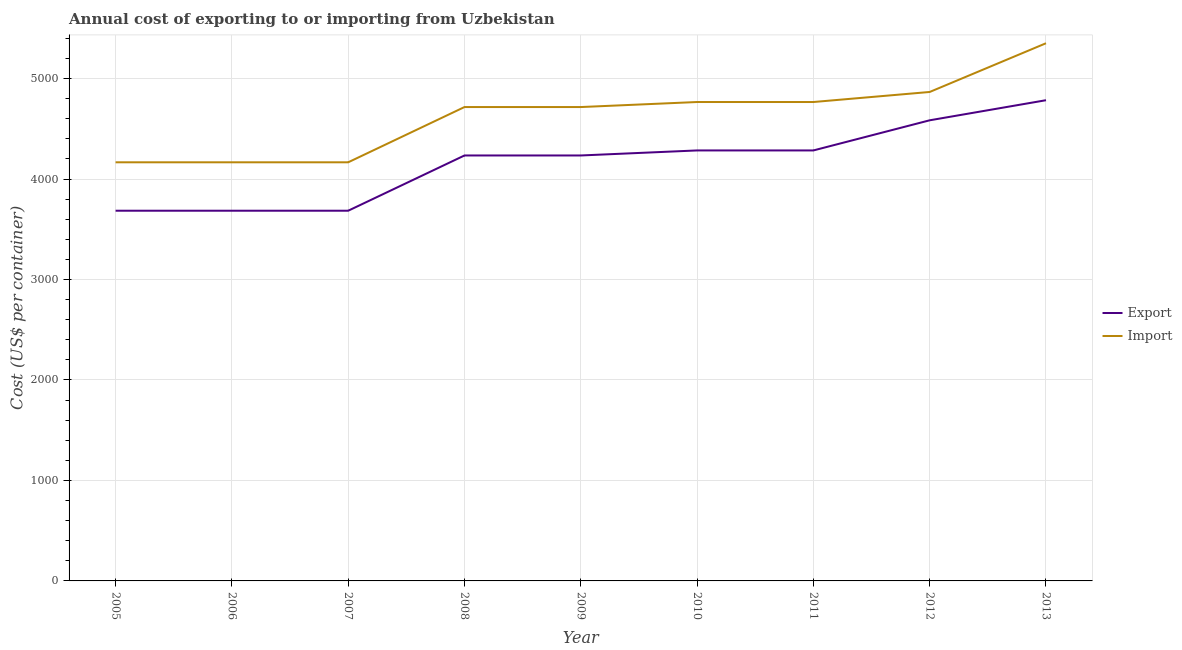Is the number of lines equal to the number of legend labels?
Your response must be concise. Yes. What is the import cost in 2012?
Your answer should be very brief. 4867. Across all years, what is the maximum import cost?
Provide a short and direct response. 5352. Across all years, what is the minimum import cost?
Offer a very short reply. 4167. In which year was the export cost maximum?
Give a very brief answer. 2013. What is the total export cost in the graph?
Offer a terse response. 3.75e+04. What is the difference between the export cost in 2008 and that in 2011?
Your answer should be very brief. -50. What is the difference between the import cost in 2007 and the export cost in 2011?
Provide a short and direct response. -118. What is the average import cost per year?
Provide a short and direct response. 4632. In the year 2006, what is the difference between the export cost and import cost?
Your answer should be very brief. -482. In how many years, is the export cost greater than 3800 US$?
Ensure brevity in your answer.  6. What is the ratio of the export cost in 2010 to that in 2012?
Offer a terse response. 0.93. Is the difference between the export cost in 2008 and 2013 greater than the difference between the import cost in 2008 and 2013?
Offer a very short reply. Yes. What is the difference between the highest and the second highest import cost?
Offer a very short reply. 485. What is the difference between the highest and the lowest import cost?
Give a very brief answer. 1185. Is the sum of the export cost in 2005 and 2011 greater than the maximum import cost across all years?
Offer a very short reply. Yes. Is the export cost strictly less than the import cost over the years?
Ensure brevity in your answer.  Yes. What is the difference between two consecutive major ticks on the Y-axis?
Your answer should be very brief. 1000. What is the title of the graph?
Keep it short and to the point. Annual cost of exporting to or importing from Uzbekistan. Does "Primary income" appear as one of the legend labels in the graph?
Provide a succinct answer. No. What is the label or title of the X-axis?
Provide a short and direct response. Year. What is the label or title of the Y-axis?
Keep it short and to the point. Cost (US$ per container). What is the Cost (US$ per container) in Export in 2005?
Offer a terse response. 3685. What is the Cost (US$ per container) of Import in 2005?
Provide a succinct answer. 4167. What is the Cost (US$ per container) in Export in 2006?
Provide a short and direct response. 3685. What is the Cost (US$ per container) in Import in 2006?
Make the answer very short. 4167. What is the Cost (US$ per container) in Export in 2007?
Provide a succinct answer. 3685. What is the Cost (US$ per container) of Import in 2007?
Make the answer very short. 4167. What is the Cost (US$ per container) of Export in 2008?
Offer a terse response. 4235. What is the Cost (US$ per container) of Import in 2008?
Offer a terse response. 4717. What is the Cost (US$ per container) of Export in 2009?
Provide a succinct answer. 4235. What is the Cost (US$ per container) of Import in 2009?
Your answer should be compact. 4717. What is the Cost (US$ per container) of Export in 2010?
Your response must be concise. 4285. What is the Cost (US$ per container) of Import in 2010?
Your answer should be compact. 4767. What is the Cost (US$ per container) of Export in 2011?
Keep it short and to the point. 4285. What is the Cost (US$ per container) of Import in 2011?
Provide a short and direct response. 4767. What is the Cost (US$ per container) in Export in 2012?
Provide a succinct answer. 4585. What is the Cost (US$ per container) in Import in 2012?
Ensure brevity in your answer.  4867. What is the Cost (US$ per container) of Export in 2013?
Your answer should be very brief. 4785. What is the Cost (US$ per container) of Import in 2013?
Ensure brevity in your answer.  5352. Across all years, what is the maximum Cost (US$ per container) of Export?
Provide a short and direct response. 4785. Across all years, what is the maximum Cost (US$ per container) of Import?
Provide a succinct answer. 5352. Across all years, what is the minimum Cost (US$ per container) in Export?
Make the answer very short. 3685. Across all years, what is the minimum Cost (US$ per container) in Import?
Ensure brevity in your answer.  4167. What is the total Cost (US$ per container) of Export in the graph?
Ensure brevity in your answer.  3.75e+04. What is the total Cost (US$ per container) of Import in the graph?
Offer a very short reply. 4.17e+04. What is the difference between the Cost (US$ per container) of Export in 2005 and that in 2006?
Your response must be concise. 0. What is the difference between the Cost (US$ per container) in Import in 2005 and that in 2006?
Your answer should be very brief. 0. What is the difference between the Cost (US$ per container) of Export in 2005 and that in 2008?
Offer a terse response. -550. What is the difference between the Cost (US$ per container) of Import in 2005 and that in 2008?
Your answer should be very brief. -550. What is the difference between the Cost (US$ per container) in Export in 2005 and that in 2009?
Ensure brevity in your answer.  -550. What is the difference between the Cost (US$ per container) of Import in 2005 and that in 2009?
Your response must be concise. -550. What is the difference between the Cost (US$ per container) of Export in 2005 and that in 2010?
Offer a very short reply. -600. What is the difference between the Cost (US$ per container) of Import in 2005 and that in 2010?
Your response must be concise. -600. What is the difference between the Cost (US$ per container) in Export in 2005 and that in 2011?
Make the answer very short. -600. What is the difference between the Cost (US$ per container) of Import in 2005 and that in 2011?
Offer a very short reply. -600. What is the difference between the Cost (US$ per container) in Export in 2005 and that in 2012?
Provide a succinct answer. -900. What is the difference between the Cost (US$ per container) of Import in 2005 and that in 2012?
Keep it short and to the point. -700. What is the difference between the Cost (US$ per container) of Export in 2005 and that in 2013?
Give a very brief answer. -1100. What is the difference between the Cost (US$ per container) in Import in 2005 and that in 2013?
Offer a terse response. -1185. What is the difference between the Cost (US$ per container) of Export in 2006 and that in 2007?
Make the answer very short. 0. What is the difference between the Cost (US$ per container) in Import in 2006 and that in 2007?
Give a very brief answer. 0. What is the difference between the Cost (US$ per container) in Export in 2006 and that in 2008?
Make the answer very short. -550. What is the difference between the Cost (US$ per container) in Import in 2006 and that in 2008?
Make the answer very short. -550. What is the difference between the Cost (US$ per container) of Export in 2006 and that in 2009?
Ensure brevity in your answer.  -550. What is the difference between the Cost (US$ per container) in Import in 2006 and that in 2009?
Give a very brief answer. -550. What is the difference between the Cost (US$ per container) in Export in 2006 and that in 2010?
Provide a short and direct response. -600. What is the difference between the Cost (US$ per container) in Import in 2006 and that in 2010?
Make the answer very short. -600. What is the difference between the Cost (US$ per container) of Export in 2006 and that in 2011?
Your answer should be very brief. -600. What is the difference between the Cost (US$ per container) in Import in 2006 and that in 2011?
Give a very brief answer. -600. What is the difference between the Cost (US$ per container) of Export in 2006 and that in 2012?
Provide a short and direct response. -900. What is the difference between the Cost (US$ per container) in Import in 2006 and that in 2012?
Your response must be concise. -700. What is the difference between the Cost (US$ per container) of Export in 2006 and that in 2013?
Ensure brevity in your answer.  -1100. What is the difference between the Cost (US$ per container) of Import in 2006 and that in 2013?
Provide a short and direct response. -1185. What is the difference between the Cost (US$ per container) of Export in 2007 and that in 2008?
Provide a succinct answer. -550. What is the difference between the Cost (US$ per container) of Import in 2007 and that in 2008?
Provide a succinct answer. -550. What is the difference between the Cost (US$ per container) in Export in 2007 and that in 2009?
Offer a terse response. -550. What is the difference between the Cost (US$ per container) in Import in 2007 and that in 2009?
Provide a succinct answer. -550. What is the difference between the Cost (US$ per container) in Export in 2007 and that in 2010?
Offer a terse response. -600. What is the difference between the Cost (US$ per container) in Import in 2007 and that in 2010?
Provide a short and direct response. -600. What is the difference between the Cost (US$ per container) in Export in 2007 and that in 2011?
Provide a short and direct response. -600. What is the difference between the Cost (US$ per container) in Import in 2007 and that in 2011?
Provide a succinct answer. -600. What is the difference between the Cost (US$ per container) of Export in 2007 and that in 2012?
Your answer should be compact. -900. What is the difference between the Cost (US$ per container) in Import in 2007 and that in 2012?
Your answer should be compact. -700. What is the difference between the Cost (US$ per container) in Export in 2007 and that in 2013?
Your answer should be compact. -1100. What is the difference between the Cost (US$ per container) in Import in 2007 and that in 2013?
Provide a succinct answer. -1185. What is the difference between the Cost (US$ per container) of Import in 2008 and that in 2010?
Keep it short and to the point. -50. What is the difference between the Cost (US$ per container) of Export in 2008 and that in 2011?
Give a very brief answer. -50. What is the difference between the Cost (US$ per container) in Import in 2008 and that in 2011?
Provide a succinct answer. -50. What is the difference between the Cost (US$ per container) in Export in 2008 and that in 2012?
Your answer should be very brief. -350. What is the difference between the Cost (US$ per container) in Import in 2008 and that in 2012?
Provide a succinct answer. -150. What is the difference between the Cost (US$ per container) in Export in 2008 and that in 2013?
Your response must be concise. -550. What is the difference between the Cost (US$ per container) in Import in 2008 and that in 2013?
Provide a succinct answer. -635. What is the difference between the Cost (US$ per container) in Import in 2009 and that in 2010?
Give a very brief answer. -50. What is the difference between the Cost (US$ per container) of Export in 2009 and that in 2011?
Your response must be concise. -50. What is the difference between the Cost (US$ per container) in Import in 2009 and that in 2011?
Make the answer very short. -50. What is the difference between the Cost (US$ per container) in Export in 2009 and that in 2012?
Offer a terse response. -350. What is the difference between the Cost (US$ per container) in Import in 2009 and that in 2012?
Ensure brevity in your answer.  -150. What is the difference between the Cost (US$ per container) of Export in 2009 and that in 2013?
Offer a very short reply. -550. What is the difference between the Cost (US$ per container) of Import in 2009 and that in 2013?
Your answer should be compact. -635. What is the difference between the Cost (US$ per container) of Export in 2010 and that in 2012?
Your answer should be very brief. -300. What is the difference between the Cost (US$ per container) of Import in 2010 and that in 2012?
Give a very brief answer. -100. What is the difference between the Cost (US$ per container) in Export in 2010 and that in 2013?
Offer a terse response. -500. What is the difference between the Cost (US$ per container) of Import in 2010 and that in 2013?
Your answer should be compact. -585. What is the difference between the Cost (US$ per container) of Export in 2011 and that in 2012?
Your response must be concise. -300. What is the difference between the Cost (US$ per container) of Import in 2011 and that in 2012?
Provide a succinct answer. -100. What is the difference between the Cost (US$ per container) of Export in 2011 and that in 2013?
Provide a short and direct response. -500. What is the difference between the Cost (US$ per container) of Import in 2011 and that in 2013?
Make the answer very short. -585. What is the difference between the Cost (US$ per container) in Export in 2012 and that in 2013?
Offer a very short reply. -200. What is the difference between the Cost (US$ per container) in Import in 2012 and that in 2013?
Ensure brevity in your answer.  -485. What is the difference between the Cost (US$ per container) in Export in 2005 and the Cost (US$ per container) in Import in 2006?
Ensure brevity in your answer.  -482. What is the difference between the Cost (US$ per container) of Export in 2005 and the Cost (US$ per container) of Import in 2007?
Your answer should be compact. -482. What is the difference between the Cost (US$ per container) in Export in 2005 and the Cost (US$ per container) in Import in 2008?
Make the answer very short. -1032. What is the difference between the Cost (US$ per container) of Export in 2005 and the Cost (US$ per container) of Import in 2009?
Offer a very short reply. -1032. What is the difference between the Cost (US$ per container) of Export in 2005 and the Cost (US$ per container) of Import in 2010?
Ensure brevity in your answer.  -1082. What is the difference between the Cost (US$ per container) of Export in 2005 and the Cost (US$ per container) of Import in 2011?
Your answer should be very brief. -1082. What is the difference between the Cost (US$ per container) of Export in 2005 and the Cost (US$ per container) of Import in 2012?
Your answer should be compact. -1182. What is the difference between the Cost (US$ per container) in Export in 2005 and the Cost (US$ per container) in Import in 2013?
Keep it short and to the point. -1667. What is the difference between the Cost (US$ per container) in Export in 2006 and the Cost (US$ per container) in Import in 2007?
Provide a short and direct response. -482. What is the difference between the Cost (US$ per container) in Export in 2006 and the Cost (US$ per container) in Import in 2008?
Ensure brevity in your answer.  -1032. What is the difference between the Cost (US$ per container) in Export in 2006 and the Cost (US$ per container) in Import in 2009?
Your answer should be compact. -1032. What is the difference between the Cost (US$ per container) in Export in 2006 and the Cost (US$ per container) in Import in 2010?
Your response must be concise. -1082. What is the difference between the Cost (US$ per container) of Export in 2006 and the Cost (US$ per container) of Import in 2011?
Make the answer very short. -1082. What is the difference between the Cost (US$ per container) of Export in 2006 and the Cost (US$ per container) of Import in 2012?
Give a very brief answer. -1182. What is the difference between the Cost (US$ per container) in Export in 2006 and the Cost (US$ per container) in Import in 2013?
Give a very brief answer. -1667. What is the difference between the Cost (US$ per container) of Export in 2007 and the Cost (US$ per container) of Import in 2008?
Give a very brief answer. -1032. What is the difference between the Cost (US$ per container) of Export in 2007 and the Cost (US$ per container) of Import in 2009?
Your answer should be very brief. -1032. What is the difference between the Cost (US$ per container) in Export in 2007 and the Cost (US$ per container) in Import in 2010?
Make the answer very short. -1082. What is the difference between the Cost (US$ per container) of Export in 2007 and the Cost (US$ per container) of Import in 2011?
Ensure brevity in your answer.  -1082. What is the difference between the Cost (US$ per container) in Export in 2007 and the Cost (US$ per container) in Import in 2012?
Provide a succinct answer. -1182. What is the difference between the Cost (US$ per container) of Export in 2007 and the Cost (US$ per container) of Import in 2013?
Offer a terse response. -1667. What is the difference between the Cost (US$ per container) of Export in 2008 and the Cost (US$ per container) of Import in 2009?
Your answer should be very brief. -482. What is the difference between the Cost (US$ per container) in Export in 2008 and the Cost (US$ per container) in Import in 2010?
Provide a short and direct response. -532. What is the difference between the Cost (US$ per container) of Export in 2008 and the Cost (US$ per container) of Import in 2011?
Your answer should be very brief. -532. What is the difference between the Cost (US$ per container) in Export in 2008 and the Cost (US$ per container) in Import in 2012?
Offer a very short reply. -632. What is the difference between the Cost (US$ per container) of Export in 2008 and the Cost (US$ per container) of Import in 2013?
Provide a succinct answer. -1117. What is the difference between the Cost (US$ per container) of Export in 2009 and the Cost (US$ per container) of Import in 2010?
Offer a very short reply. -532. What is the difference between the Cost (US$ per container) of Export in 2009 and the Cost (US$ per container) of Import in 2011?
Make the answer very short. -532. What is the difference between the Cost (US$ per container) in Export in 2009 and the Cost (US$ per container) in Import in 2012?
Your answer should be compact. -632. What is the difference between the Cost (US$ per container) in Export in 2009 and the Cost (US$ per container) in Import in 2013?
Keep it short and to the point. -1117. What is the difference between the Cost (US$ per container) of Export in 2010 and the Cost (US$ per container) of Import in 2011?
Make the answer very short. -482. What is the difference between the Cost (US$ per container) of Export in 2010 and the Cost (US$ per container) of Import in 2012?
Your answer should be very brief. -582. What is the difference between the Cost (US$ per container) in Export in 2010 and the Cost (US$ per container) in Import in 2013?
Your response must be concise. -1067. What is the difference between the Cost (US$ per container) of Export in 2011 and the Cost (US$ per container) of Import in 2012?
Provide a short and direct response. -582. What is the difference between the Cost (US$ per container) in Export in 2011 and the Cost (US$ per container) in Import in 2013?
Keep it short and to the point. -1067. What is the difference between the Cost (US$ per container) of Export in 2012 and the Cost (US$ per container) of Import in 2013?
Make the answer very short. -767. What is the average Cost (US$ per container) in Export per year?
Provide a short and direct response. 4162.78. What is the average Cost (US$ per container) in Import per year?
Provide a short and direct response. 4632. In the year 2005, what is the difference between the Cost (US$ per container) of Export and Cost (US$ per container) of Import?
Your answer should be very brief. -482. In the year 2006, what is the difference between the Cost (US$ per container) in Export and Cost (US$ per container) in Import?
Make the answer very short. -482. In the year 2007, what is the difference between the Cost (US$ per container) in Export and Cost (US$ per container) in Import?
Offer a very short reply. -482. In the year 2008, what is the difference between the Cost (US$ per container) of Export and Cost (US$ per container) of Import?
Offer a very short reply. -482. In the year 2009, what is the difference between the Cost (US$ per container) in Export and Cost (US$ per container) in Import?
Give a very brief answer. -482. In the year 2010, what is the difference between the Cost (US$ per container) in Export and Cost (US$ per container) in Import?
Ensure brevity in your answer.  -482. In the year 2011, what is the difference between the Cost (US$ per container) of Export and Cost (US$ per container) of Import?
Provide a short and direct response. -482. In the year 2012, what is the difference between the Cost (US$ per container) of Export and Cost (US$ per container) of Import?
Your response must be concise. -282. In the year 2013, what is the difference between the Cost (US$ per container) in Export and Cost (US$ per container) in Import?
Offer a terse response. -567. What is the ratio of the Cost (US$ per container) of Export in 2005 to that in 2006?
Your answer should be very brief. 1. What is the ratio of the Cost (US$ per container) in Export in 2005 to that in 2008?
Your answer should be very brief. 0.87. What is the ratio of the Cost (US$ per container) in Import in 2005 to that in 2008?
Make the answer very short. 0.88. What is the ratio of the Cost (US$ per container) in Export in 2005 to that in 2009?
Your answer should be compact. 0.87. What is the ratio of the Cost (US$ per container) in Import in 2005 to that in 2009?
Give a very brief answer. 0.88. What is the ratio of the Cost (US$ per container) of Export in 2005 to that in 2010?
Give a very brief answer. 0.86. What is the ratio of the Cost (US$ per container) of Import in 2005 to that in 2010?
Offer a terse response. 0.87. What is the ratio of the Cost (US$ per container) of Export in 2005 to that in 2011?
Your answer should be compact. 0.86. What is the ratio of the Cost (US$ per container) of Import in 2005 to that in 2011?
Make the answer very short. 0.87. What is the ratio of the Cost (US$ per container) in Export in 2005 to that in 2012?
Make the answer very short. 0.8. What is the ratio of the Cost (US$ per container) in Import in 2005 to that in 2012?
Your answer should be compact. 0.86. What is the ratio of the Cost (US$ per container) of Export in 2005 to that in 2013?
Keep it short and to the point. 0.77. What is the ratio of the Cost (US$ per container) of Import in 2005 to that in 2013?
Keep it short and to the point. 0.78. What is the ratio of the Cost (US$ per container) of Export in 2006 to that in 2008?
Your response must be concise. 0.87. What is the ratio of the Cost (US$ per container) of Import in 2006 to that in 2008?
Provide a short and direct response. 0.88. What is the ratio of the Cost (US$ per container) in Export in 2006 to that in 2009?
Your response must be concise. 0.87. What is the ratio of the Cost (US$ per container) in Import in 2006 to that in 2009?
Provide a short and direct response. 0.88. What is the ratio of the Cost (US$ per container) in Export in 2006 to that in 2010?
Offer a terse response. 0.86. What is the ratio of the Cost (US$ per container) in Import in 2006 to that in 2010?
Your answer should be very brief. 0.87. What is the ratio of the Cost (US$ per container) of Export in 2006 to that in 2011?
Ensure brevity in your answer.  0.86. What is the ratio of the Cost (US$ per container) of Import in 2006 to that in 2011?
Provide a short and direct response. 0.87. What is the ratio of the Cost (US$ per container) in Export in 2006 to that in 2012?
Provide a short and direct response. 0.8. What is the ratio of the Cost (US$ per container) in Import in 2006 to that in 2012?
Provide a succinct answer. 0.86. What is the ratio of the Cost (US$ per container) in Export in 2006 to that in 2013?
Your answer should be very brief. 0.77. What is the ratio of the Cost (US$ per container) of Import in 2006 to that in 2013?
Provide a short and direct response. 0.78. What is the ratio of the Cost (US$ per container) of Export in 2007 to that in 2008?
Provide a succinct answer. 0.87. What is the ratio of the Cost (US$ per container) of Import in 2007 to that in 2008?
Give a very brief answer. 0.88. What is the ratio of the Cost (US$ per container) in Export in 2007 to that in 2009?
Offer a very short reply. 0.87. What is the ratio of the Cost (US$ per container) of Import in 2007 to that in 2009?
Give a very brief answer. 0.88. What is the ratio of the Cost (US$ per container) of Export in 2007 to that in 2010?
Offer a very short reply. 0.86. What is the ratio of the Cost (US$ per container) in Import in 2007 to that in 2010?
Your answer should be compact. 0.87. What is the ratio of the Cost (US$ per container) of Export in 2007 to that in 2011?
Provide a succinct answer. 0.86. What is the ratio of the Cost (US$ per container) in Import in 2007 to that in 2011?
Your response must be concise. 0.87. What is the ratio of the Cost (US$ per container) in Export in 2007 to that in 2012?
Ensure brevity in your answer.  0.8. What is the ratio of the Cost (US$ per container) in Import in 2007 to that in 2012?
Give a very brief answer. 0.86. What is the ratio of the Cost (US$ per container) in Export in 2007 to that in 2013?
Offer a terse response. 0.77. What is the ratio of the Cost (US$ per container) of Import in 2007 to that in 2013?
Offer a very short reply. 0.78. What is the ratio of the Cost (US$ per container) in Import in 2008 to that in 2009?
Your answer should be compact. 1. What is the ratio of the Cost (US$ per container) of Export in 2008 to that in 2010?
Your answer should be compact. 0.99. What is the ratio of the Cost (US$ per container) of Import in 2008 to that in 2010?
Make the answer very short. 0.99. What is the ratio of the Cost (US$ per container) in Export in 2008 to that in 2011?
Your answer should be compact. 0.99. What is the ratio of the Cost (US$ per container) in Export in 2008 to that in 2012?
Offer a terse response. 0.92. What is the ratio of the Cost (US$ per container) in Import in 2008 to that in 2012?
Your answer should be compact. 0.97. What is the ratio of the Cost (US$ per container) in Export in 2008 to that in 2013?
Your answer should be very brief. 0.89. What is the ratio of the Cost (US$ per container) in Import in 2008 to that in 2013?
Your answer should be compact. 0.88. What is the ratio of the Cost (US$ per container) in Export in 2009 to that in 2010?
Ensure brevity in your answer.  0.99. What is the ratio of the Cost (US$ per container) of Export in 2009 to that in 2011?
Your response must be concise. 0.99. What is the ratio of the Cost (US$ per container) of Import in 2009 to that in 2011?
Ensure brevity in your answer.  0.99. What is the ratio of the Cost (US$ per container) of Export in 2009 to that in 2012?
Offer a terse response. 0.92. What is the ratio of the Cost (US$ per container) of Import in 2009 to that in 2012?
Ensure brevity in your answer.  0.97. What is the ratio of the Cost (US$ per container) in Export in 2009 to that in 2013?
Offer a terse response. 0.89. What is the ratio of the Cost (US$ per container) in Import in 2009 to that in 2013?
Your response must be concise. 0.88. What is the ratio of the Cost (US$ per container) of Export in 2010 to that in 2011?
Provide a short and direct response. 1. What is the ratio of the Cost (US$ per container) of Export in 2010 to that in 2012?
Your response must be concise. 0.93. What is the ratio of the Cost (US$ per container) of Import in 2010 to that in 2012?
Give a very brief answer. 0.98. What is the ratio of the Cost (US$ per container) of Export in 2010 to that in 2013?
Your response must be concise. 0.9. What is the ratio of the Cost (US$ per container) of Import in 2010 to that in 2013?
Offer a very short reply. 0.89. What is the ratio of the Cost (US$ per container) in Export in 2011 to that in 2012?
Ensure brevity in your answer.  0.93. What is the ratio of the Cost (US$ per container) in Import in 2011 to that in 2012?
Keep it short and to the point. 0.98. What is the ratio of the Cost (US$ per container) of Export in 2011 to that in 2013?
Ensure brevity in your answer.  0.9. What is the ratio of the Cost (US$ per container) of Import in 2011 to that in 2013?
Provide a succinct answer. 0.89. What is the ratio of the Cost (US$ per container) in Export in 2012 to that in 2013?
Your answer should be compact. 0.96. What is the ratio of the Cost (US$ per container) of Import in 2012 to that in 2013?
Your answer should be compact. 0.91. What is the difference between the highest and the second highest Cost (US$ per container) in Export?
Make the answer very short. 200. What is the difference between the highest and the second highest Cost (US$ per container) in Import?
Your response must be concise. 485. What is the difference between the highest and the lowest Cost (US$ per container) of Export?
Provide a succinct answer. 1100. What is the difference between the highest and the lowest Cost (US$ per container) of Import?
Offer a terse response. 1185. 